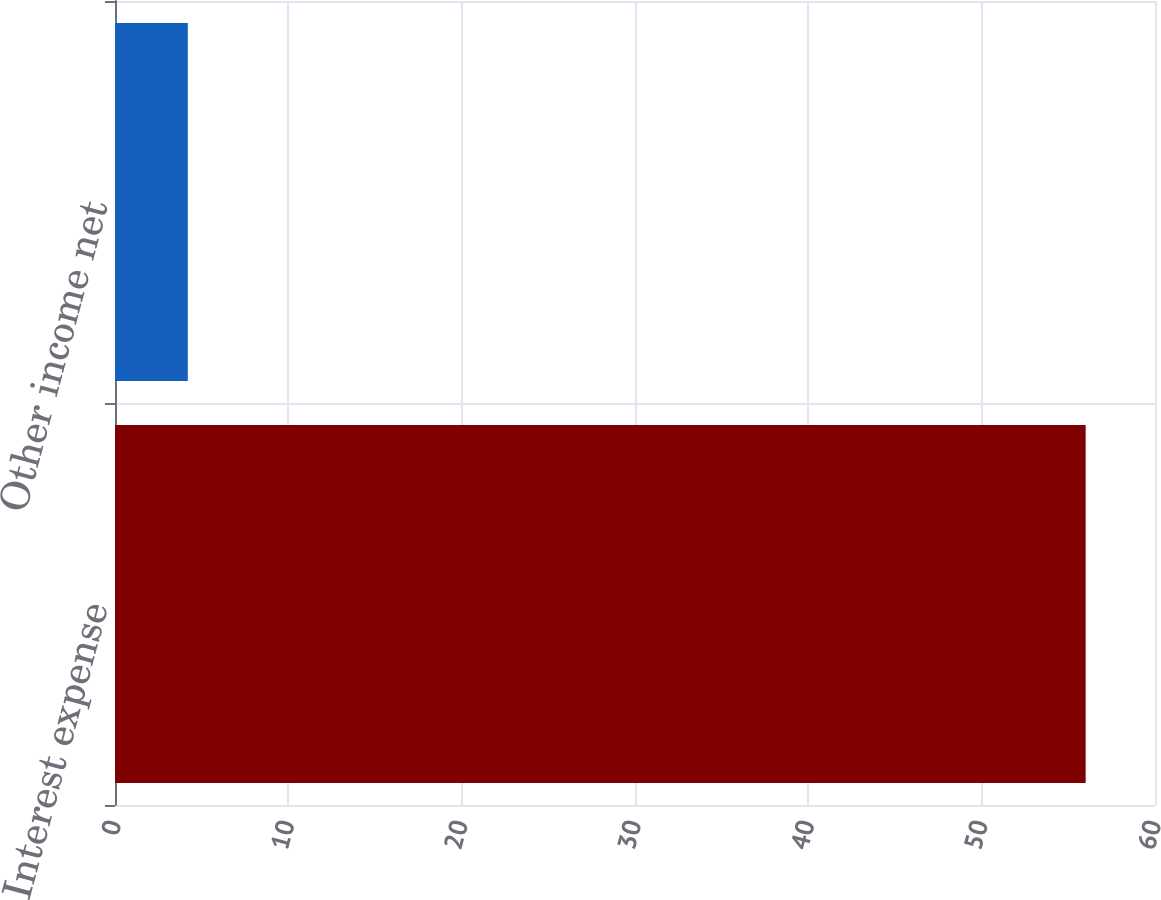Convert chart. <chart><loc_0><loc_0><loc_500><loc_500><bar_chart><fcel>Interest expense<fcel>Other income net<nl><fcel>56<fcel>4.2<nl></chart> 